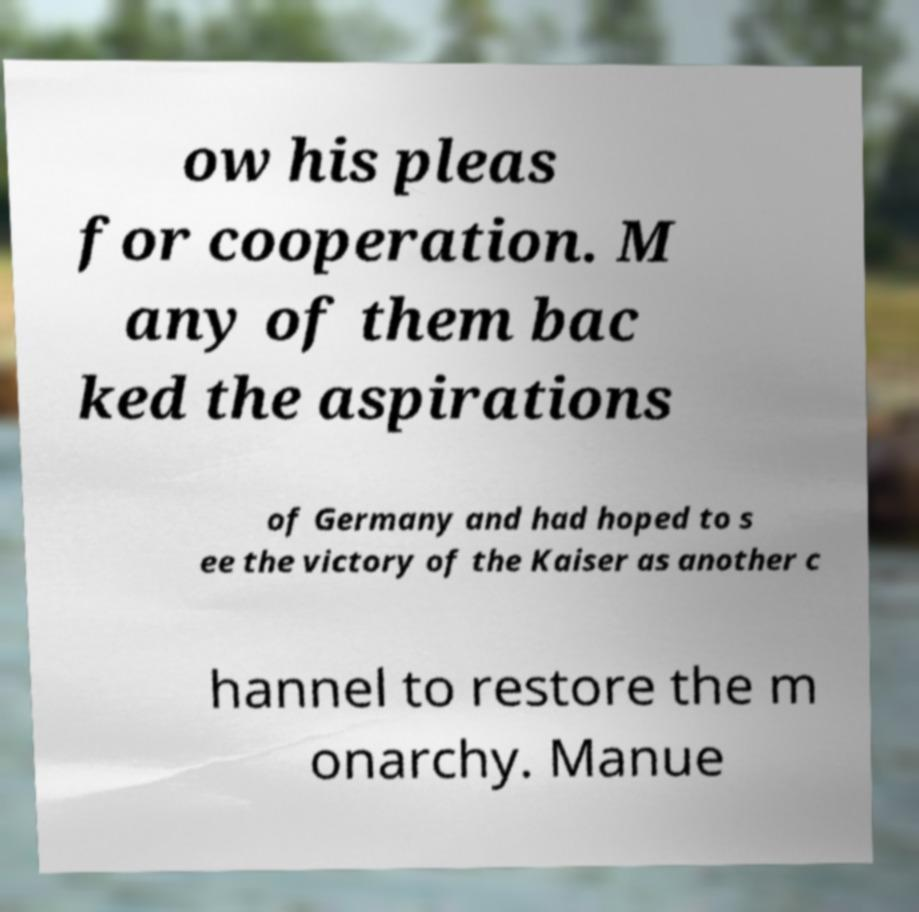There's text embedded in this image that I need extracted. Can you transcribe it verbatim? ow his pleas for cooperation. M any of them bac ked the aspirations of Germany and had hoped to s ee the victory of the Kaiser as another c hannel to restore the m onarchy. Manue 